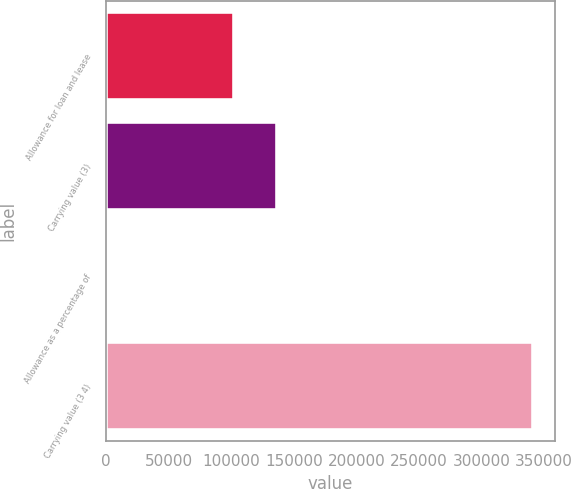Convert chart to OTSL. <chart><loc_0><loc_0><loc_500><loc_500><bar_chart><fcel>Allowance for loan and lease<fcel>Carrying value (3)<fcel>Allowance as a percentage of<fcel>Carrying value (3 4)<nl><fcel>102451<fcel>136601<fcel>0.81<fcel>341502<nl></chart> 